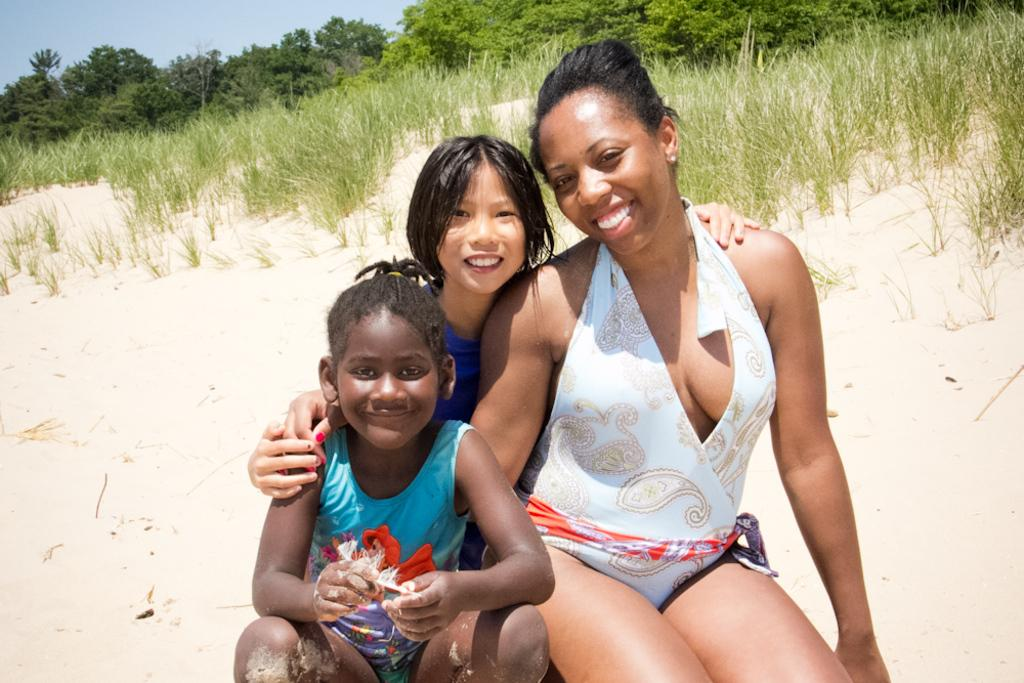Who or what can be seen in the image? There are people in the image. What type of natural environment is depicted in the image? There are trees, sand, and grass in the image. What is visible at the top of the image? The sky is visible at the top of the image. What type of bait is being used by the people in the image? There is no mention of bait or fishing in the image; it features people in a natural environment with trees, sand, grass, and the sky. 